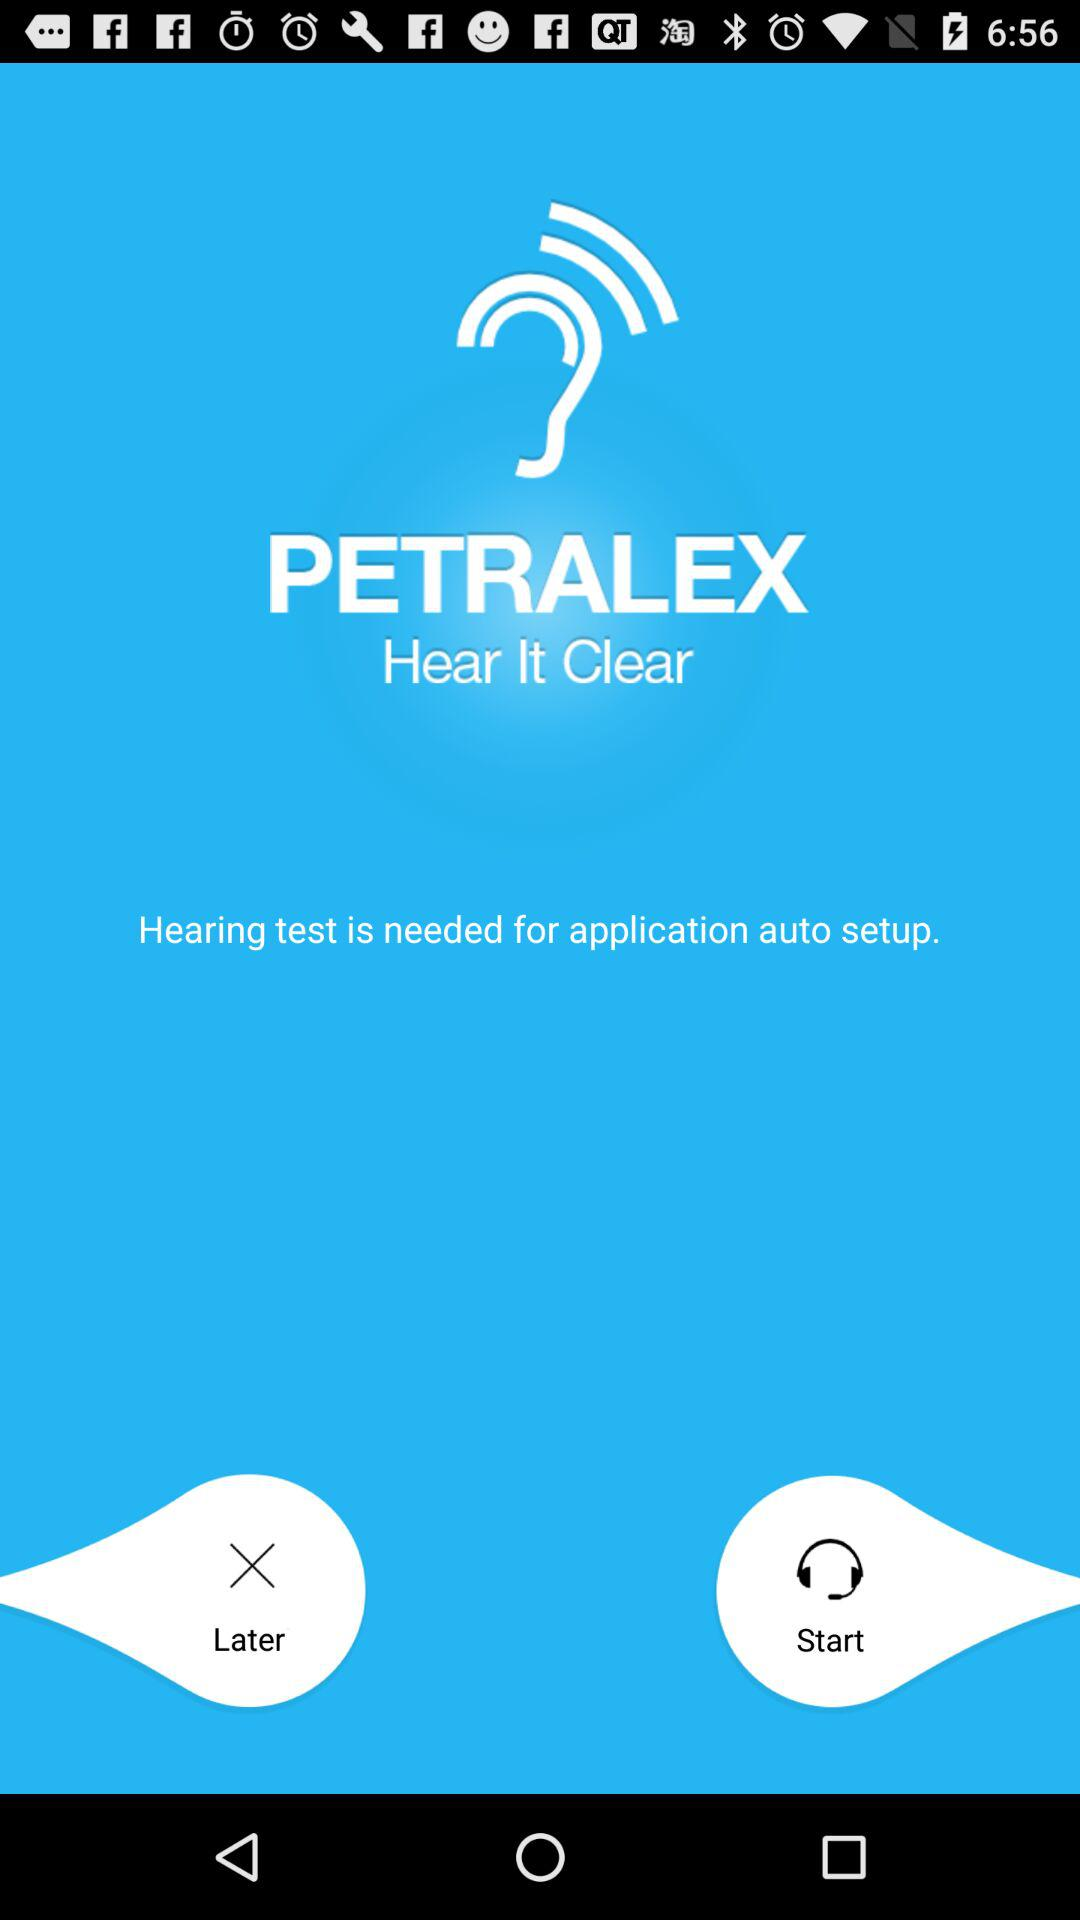What is the name of the application? The name of the application is Petralex. 